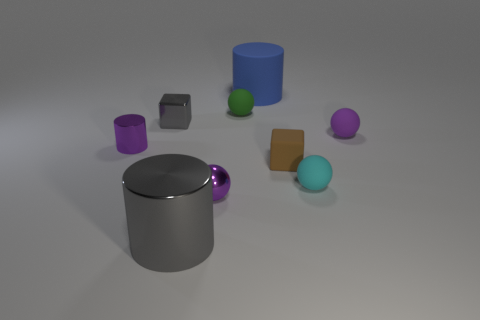Subtract all purple metal spheres. How many spheres are left? 3 Add 1 large blue cylinders. How many objects exist? 10 Subtract all brown cubes. How many cubes are left? 1 Subtract 2 cylinders. How many cylinders are left? 1 Subtract all cylinders. How many objects are left? 6 Subtract all blue cubes. Subtract all gray balls. How many cubes are left? 2 Subtract all purple cubes. How many purple cylinders are left? 1 Subtract all gray shiny cylinders. Subtract all purple rubber things. How many objects are left? 7 Add 1 tiny metal cylinders. How many tiny metal cylinders are left? 2 Add 8 big cyan matte spheres. How many big cyan matte spheres exist? 8 